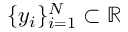Convert formula to latex. <formula><loc_0><loc_0><loc_500><loc_500>\{ y _ { i } \} _ { i = 1 } ^ { N } \subset \mathbb { R }</formula> 